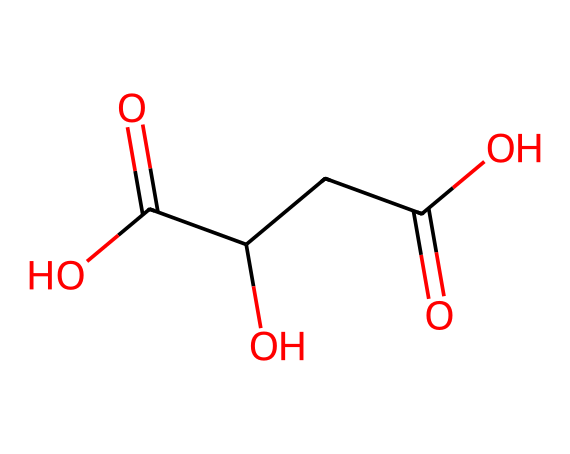how many carbon atoms are present in this structure? By examining the SMILES representation, we count the number of carbon (C) atoms. The structure has the sequence, indicating there are four carbon atoms in total.
Answer: four what functional groups are present in malic acid? Looking at the SMILES, we can identify that the structure contains two carboxylic acid groups (-COOH) and one hydroxyl group (-OH), which are characteristic functional groups.
Answer: carboxylic acid and hydroxyl what is the molecular formula of malic acid? To determine the molecular formula, we count each type of atom from the SMILES notation: 4 carbon (C), 6 hydrogen (H), and 5 oxygen (O) atoms, resulting in the formula C4H6O5.
Answer: C4H6O5 why is malic acid considered an acid? Malic acid contains carboxylic acid functional groups (-COOH), which are responsible for its acidic properties, allowing it to donate protons (H+) in solution.
Answer: it contains carboxylic acid groups how many total bonds are present in malic acid? We can analyze the structure derived from the SMILES to count all the bonds: each carbon typically forms four bonds, and we consider single and double bonds; thus, there are ten bonds in total when counted properly.
Answer: ten what sensory experience might malic acid contribute to playdough? Malic acid has a fruity, tart flavor profile, which can contribute to the sensory experience by creating a pleasant, fruity scent in playdough, stimulating olfactory senses.
Answer: fruity scent 